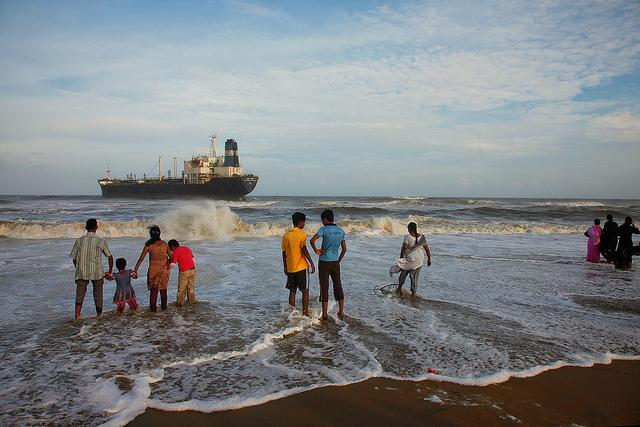How many people are visible? ten 